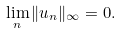<formula> <loc_0><loc_0><loc_500><loc_500>\lim _ { n } \| u _ { n } \| _ { \infty } = 0 .</formula> 